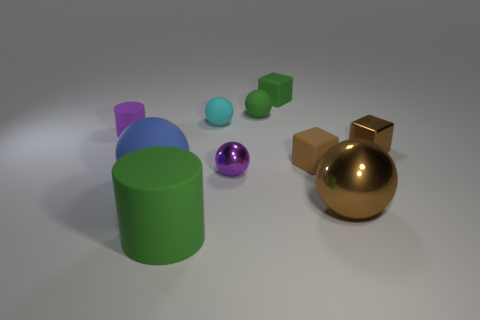Subtract all small green matte spheres. How many spheres are left? 4 Subtract 3 balls. How many balls are left? 2 Subtract all blue spheres. How many spheres are left? 4 Subtract all green spheres. Subtract all purple blocks. How many spheres are left? 4 Subtract all cylinders. How many objects are left? 8 Add 7 green rubber spheres. How many green rubber spheres exist? 8 Subtract 0 red blocks. How many objects are left? 10 Subtract all brown metal blocks. Subtract all big balls. How many objects are left? 7 Add 2 blue matte spheres. How many blue matte spheres are left? 3 